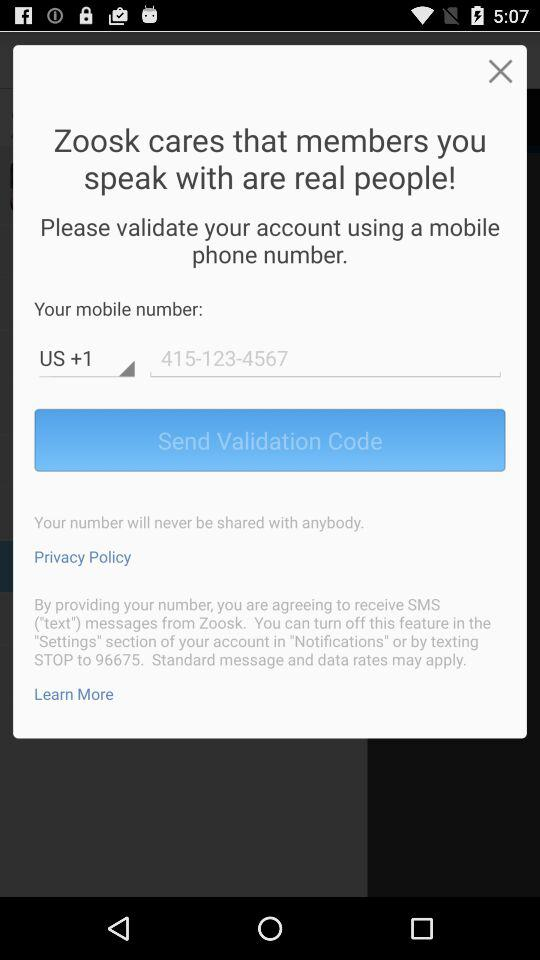What is the country code? The country code is +1. 